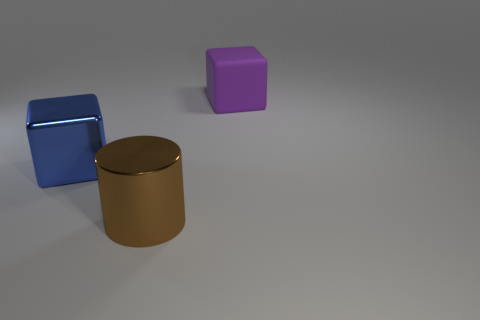There is another object that is the same shape as the purple object; what size is it?
Give a very brief answer. Large. What is the shape of the purple rubber object that is on the right side of the large metal object that is behind the metal thing that is on the right side of the blue metal cube?
Ensure brevity in your answer.  Cube. There is another large object that is the same shape as the big rubber object; what color is it?
Keep it short and to the point. Blue. There is a object that is behind the brown cylinder and in front of the purple rubber thing; what is its size?
Your answer should be very brief. Large. There is a metal thing to the right of the metallic thing that is to the left of the brown metal thing; what number of large blocks are in front of it?
Offer a terse response. 0. How many tiny things are blocks or blue rubber cylinders?
Keep it short and to the point. 0. Are the big cube in front of the rubber object and the purple block made of the same material?
Offer a terse response. No. What is the material of the large object that is behind the metal thing that is to the left of the big metal thing that is on the right side of the blue metal thing?
Offer a very short reply. Rubber. What number of metal things are either cylinders or big cubes?
Keep it short and to the point. 2. Are there any large gray metal balls?
Offer a terse response. No. 